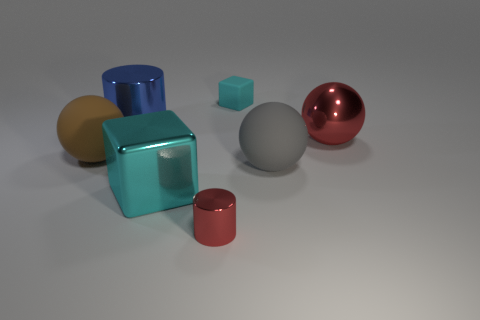Subtract all shiny spheres. How many spheres are left? 2 Add 1 small cyan matte cylinders. How many objects exist? 8 Subtract all red cylinders. How many cylinders are left? 1 Subtract all blocks. How many objects are left? 5 Subtract 3 balls. How many balls are left? 0 Subtract all red cubes. How many gray spheres are left? 1 Subtract all blue cylinders. Subtract all large shiny balls. How many objects are left? 5 Add 7 brown matte balls. How many brown matte balls are left? 8 Add 6 red metal things. How many red metal things exist? 8 Subtract 1 blue cylinders. How many objects are left? 6 